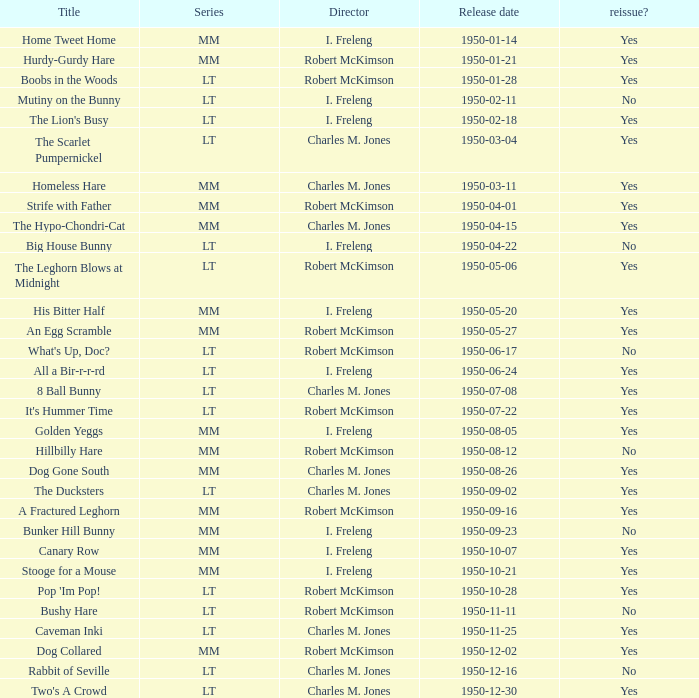Give me the full table as a dictionary. {'header': ['Title', 'Series', 'Director', 'Release date', 'reissue?'], 'rows': [['Home Tweet Home', 'MM', 'I. Freleng', '1950-01-14', 'Yes'], ['Hurdy-Gurdy Hare', 'MM', 'Robert McKimson', '1950-01-21', 'Yes'], ['Boobs in the Woods', 'LT', 'Robert McKimson', '1950-01-28', 'Yes'], ['Mutiny on the Bunny', 'LT', 'I. Freleng', '1950-02-11', 'No'], ["The Lion's Busy", 'LT', 'I. Freleng', '1950-02-18', 'Yes'], ['The Scarlet Pumpernickel', 'LT', 'Charles M. Jones', '1950-03-04', 'Yes'], ['Homeless Hare', 'MM', 'Charles M. Jones', '1950-03-11', 'Yes'], ['Strife with Father', 'MM', 'Robert McKimson', '1950-04-01', 'Yes'], ['The Hypo-Chondri-Cat', 'MM', 'Charles M. Jones', '1950-04-15', 'Yes'], ['Big House Bunny', 'LT', 'I. Freleng', '1950-04-22', 'No'], ['The Leghorn Blows at Midnight', 'LT', 'Robert McKimson', '1950-05-06', 'Yes'], ['His Bitter Half', 'MM', 'I. Freleng', '1950-05-20', 'Yes'], ['An Egg Scramble', 'MM', 'Robert McKimson', '1950-05-27', 'Yes'], ["What's Up, Doc?", 'LT', 'Robert McKimson', '1950-06-17', 'No'], ['All a Bir-r-r-rd', 'LT', 'I. Freleng', '1950-06-24', 'Yes'], ['8 Ball Bunny', 'LT', 'Charles M. Jones', '1950-07-08', 'Yes'], ["It's Hummer Time", 'LT', 'Robert McKimson', '1950-07-22', 'Yes'], ['Golden Yeggs', 'MM', 'I. Freleng', '1950-08-05', 'Yes'], ['Hillbilly Hare', 'MM', 'Robert McKimson', '1950-08-12', 'No'], ['Dog Gone South', 'MM', 'Charles M. Jones', '1950-08-26', 'Yes'], ['The Ducksters', 'LT', 'Charles M. Jones', '1950-09-02', 'Yes'], ['A Fractured Leghorn', 'MM', 'Robert McKimson', '1950-09-16', 'Yes'], ['Bunker Hill Bunny', 'MM', 'I. Freleng', '1950-09-23', 'No'], ['Canary Row', 'MM', 'I. Freleng', '1950-10-07', 'Yes'], ['Stooge for a Mouse', 'MM', 'I. Freleng', '1950-10-21', 'Yes'], ["Pop 'Im Pop!", 'LT', 'Robert McKimson', '1950-10-28', 'Yes'], ['Bushy Hare', 'LT', 'Robert McKimson', '1950-11-11', 'No'], ['Caveman Inki', 'LT', 'Charles M. Jones', '1950-11-25', 'Yes'], ['Dog Collared', 'MM', 'Robert McKimson', '1950-12-02', 'Yes'], ['Rabbit of Seville', 'LT', 'Charles M. Jones', '1950-12-16', 'No'], ["Two's A Crowd", 'LT', 'Charles M. Jones', '1950-12-30', 'Yes']]} Who guided the direction of bunker hill bunny? I. Freleng. 